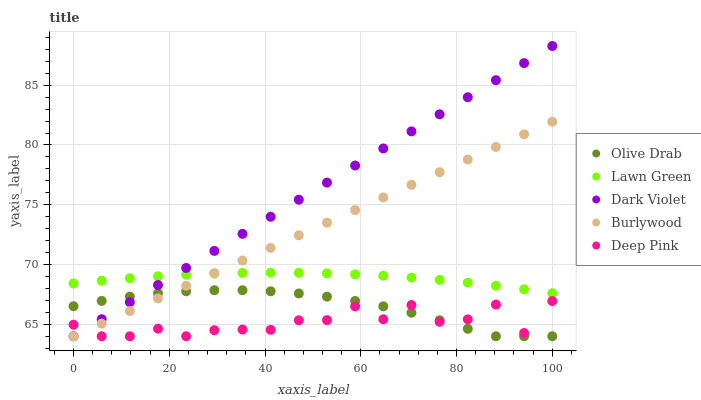Does Deep Pink have the minimum area under the curve?
Answer yes or no. Yes. Does Dark Violet have the maximum area under the curve?
Answer yes or no. Yes. Does Lawn Green have the minimum area under the curve?
Answer yes or no. No. Does Lawn Green have the maximum area under the curve?
Answer yes or no. No. Is Dark Violet the smoothest?
Answer yes or no. Yes. Is Deep Pink the roughest?
Answer yes or no. Yes. Is Lawn Green the smoothest?
Answer yes or no. No. Is Lawn Green the roughest?
Answer yes or no. No. Does Burlywood have the lowest value?
Answer yes or no. Yes. Does Lawn Green have the lowest value?
Answer yes or no. No. Does Dark Violet have the highest value?
Answer yes or no. Yes. Does Lawn Green have the highest value?
Answer yes or no. No. Is Olive Drab less than Lawn Green?
Answer yes or no. Yes. Is Lawn Green greater than Deep Pink?
Answer yes or no. Yes. Does Burlywood intersect Lawn Green?
Answer yes or no. Yes. Is Burlywood less than Lawn Green?
Answer yes or no. No. Is Burlywood greater than Lawn Green?
Answer yes or no. No. Does Olive Drab intersect Lawn Green?
Answer yes or no. No. 